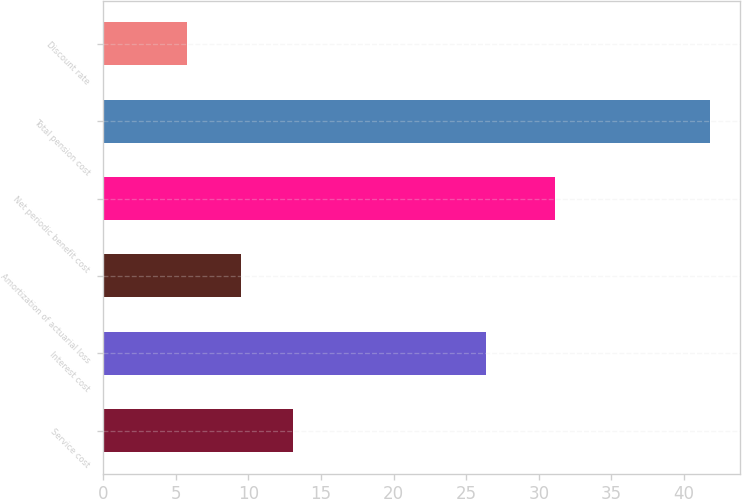Convert chart to OTSL. <chart><loc_0><loc_0><loc_500><loc_500><bar_chart><fcel>Service cost<fcel>Interest cost<fcel>Amortization of actuarial loss<fcel>Net periodic benefit cost<fcel>Total pension cost<fcel>Discount rate<nl><fcel>13.11<fcel>26.4<fcel>9.5<fcel>31.1<fcel>41.8<fcel>5.75<nl></chart> 